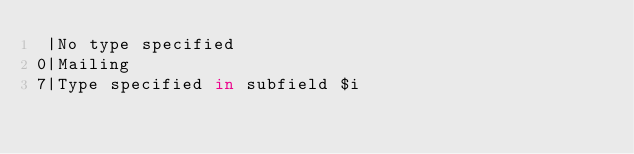Convert code to text. <code><loc_0><loc_0><loc_500><loc_500><_SQL_> |No type specified 
0|Mailing 
7|Type specified in subfield $i </code> 